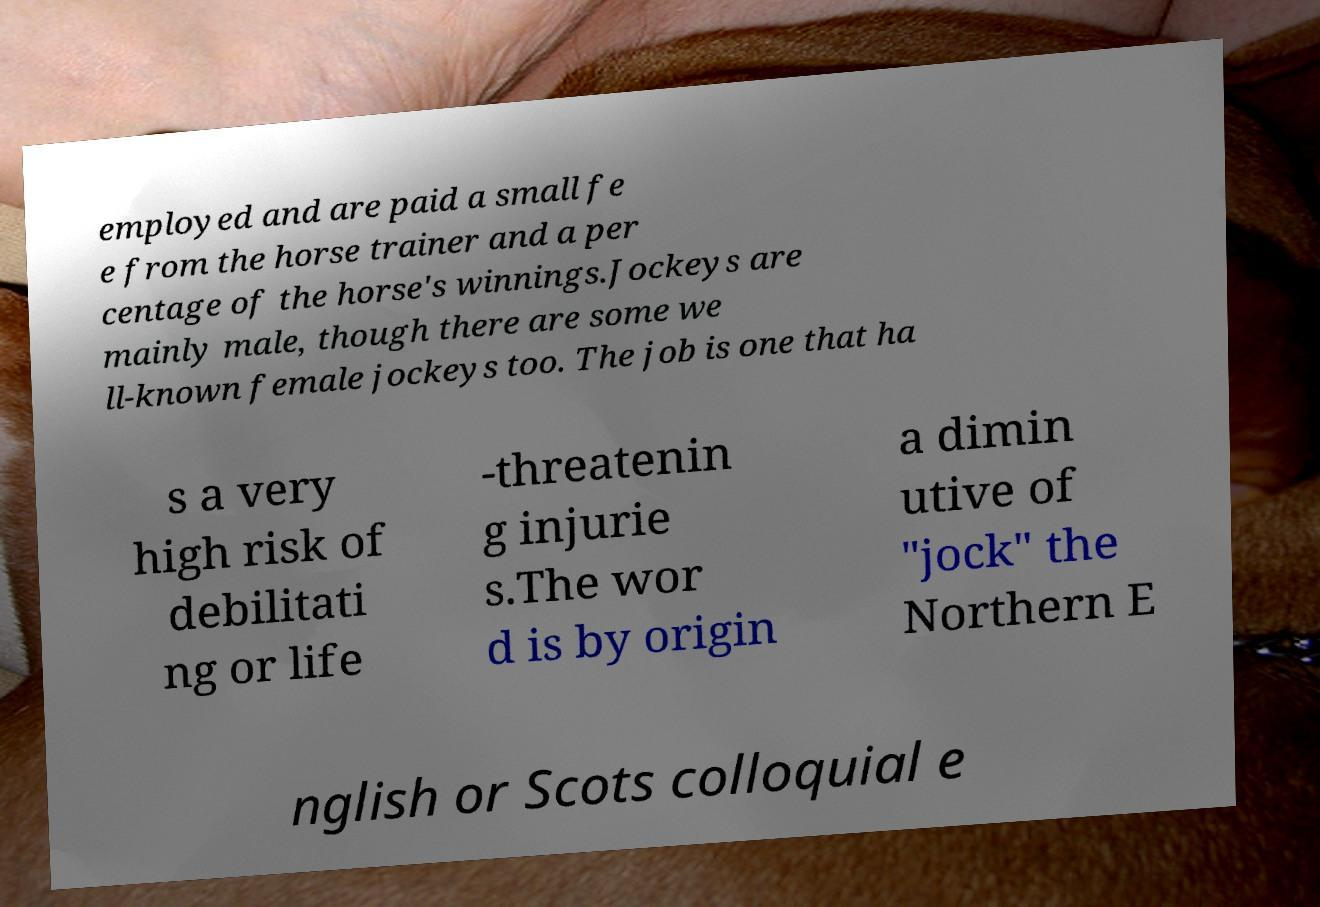Please identify and transcribe the text found in this image. employed and are paid a small fe e from the horse trainer and a per centage of the horse's winnings.Jockeys are mainly male, though there are some we ll-known female jockeys too. The job is one that ha s a very high risk of debilitati ng or life -threatenin g injurie s.The wor d is by origin a dimin utive of "jock" the Northern E nglish or Scots colloquial e 